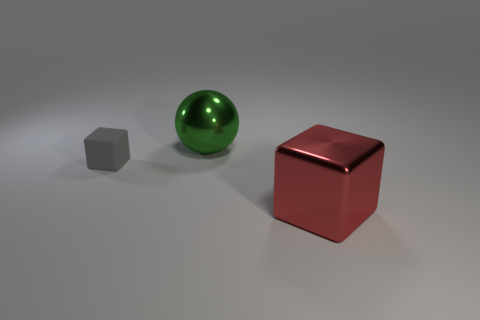Is there anything else that is the same size as the gray cube?
Provide a succinct answer. No. How many shiny spheres are the same size as the green thing?
Your answer should be very brief. 0. Are there an equal number of gray rubber cubes that are left of the gray object and big green things in front of the red object?
Offer a very short reply. Yes. Are the red cube and the tiny cube made of the same material?
Your response must be concise. No. There is a big object that is behind the tiny matte thing; are there any big spheres behind it?
Offer a terse response. No. Are there any large yellow things that have the same shape as the green object?
Provide a short and direct response. No. Do the metallic cube and the metallic sphere have the same color?
Provide a succinct answer. No. There is a object on the left side of the large metal thing behind the tiny rubber cube; what is it made of?
Offer a terse response. Rubber. The red metal block has what size?
Your response must be concise. Large. What size is the object that is the same material as the green ball?
Provide a succinct answer. Large. 